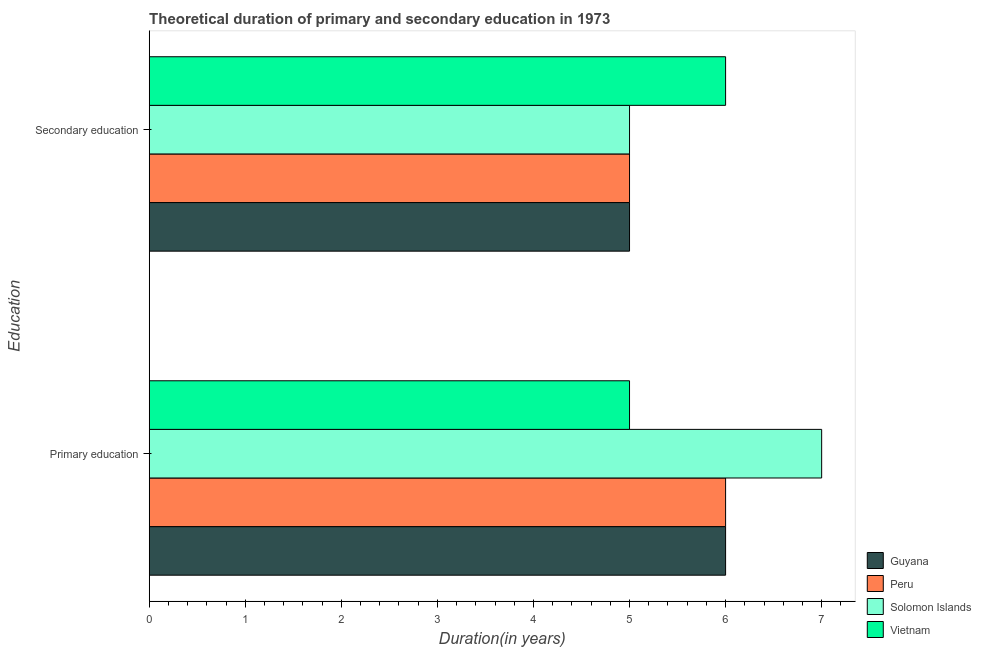What is the label of the 1st group of bars from the top?
Give a very brief answer. Secondary education. What is the duration of secondary education in Peru?
Provide a succinct answer. 5. Across all countries, what is the minimum duration of primary education?
Provide a succinct answer. 5. In which country was the duration of secondary education maximum?
Make the answer very short. Vietnam. In which country was the duration of primary education minimum?
Your answer should be compact. Vietnam. What is the total duration of primary education in the graph?
Offer a very short reply. 24. What is the difference between the duration of primary education in Guyana and that in Vietnam?
Your answer should be compact. 1. What is the difference between the duration of secondary education in Solomon Islands and the duration of primary education in Guyana?
Ensure brevity in your answer.  -1. What is the average duration of secondary education per country?
Keep it short and to the point. 5.25. What is the difference between the duration of secondary education and duration of primary education in Solomon Islands?
Ensure brevity in your answer.  -2. In how many countries, is the duration of secondary education greater than 1.8 years?
Ensure brevity in your answer.  4. Is the duration of primary education in Peru less than that in Solomon Islands?
Provide a succinct answer. Yes. In how many countries, is the duration of primary education greater than the average duration of primary education taken over all countries?
Ensure brevity in your answer.  1. What does the 2nd bar from the top in Secondary education represents?
Offer a very short reply. Solomon Islands. What does the 1st bar from the bottom in Primary education represents?
Provide a succinct answer. Guyana. Are all the bars in the graph horizontal?
Your response must be concise. Yes. Are the values on the major ticks of X-axis written in scientific E-notation?
Your answer should be very brief. No. How many legend labels are there?
Give a very brief answer. 4. How are the legend labels stacked?
Provide a short and direct response. Vertical. What is the title of the graph?
Make the answer very short. Theoretical duration of primary and secondary education in 1973. What is the label or title of the X-axis?
Your answer should be compact. Duration(in years). What is the label or title of the Y-axis?
Provide a short and direct response. Education. What is the Duration(in years) of Guyana in Primary education?
Offer a very short reply. 6. What is the Duration(in years) in Peru in Primary education?
Give a very brief answer. 6. What is the Duration(in years) in Vietnam in Primary education?
Your answer should be compact. 5. What is the Duration(in years) of Solomon Islands in Secondary education?
Offer a terse response. 5. What is the Duration(in years) in Vietnam in Secondary education?
Ensure brevity in your answer.  6. Across all Education, what is the maximum Duration(in years) in Peru?
Provide a short and direct response. 6. Across all Education, what is the maximum Duration(in years) of Solomon Islands?
Keep it short and to the point. 7. Across all Education, what is the maximum Duration(in years) of Vietnam?
Give a very brief answer. 6. Across all Education, what is the minimum Duration(in years) of Guyana?
Give a very brief answer. 5. Across all Education, what is the minimum Duration(in years) of Peru?
Provide a short and direct response. 5. What is the total Duration(in years) in Peru in the graph?
Your answer should be very brief. 11. What is the difference between the Duration(in years) of Peru in Primary education and that in Secondary education?
Offer a terse response. 1. What is the difference between the Duration(in years) of Solomon Islands in Primary education and that in Secondary education?
Keep it short and to the point. 2. What is the difference between the Duration(in years) of Guyana in Primary education and the Duration(in years) of Solomon Islands in Secondary education?
Give a very brief answer. 1. What is the difference between the Duration(in years) in Peru in Primary education and the Duration(in years) in Solomon Islands in Secondary education?
Keep it short and to the point. 1. What is the difference between the Duration(in years) of Peru in Primary education and the Duration(in years) of Vietnam in Secondary education?
Provide a succinct answer. 0. What is the average Duration(in years) of Guyana per Education?
Offer a very short reply. 5.5. What is the average Duration(in years) of Peru per Education?
Provide a short and direct response. 5.5. What is the average Duration(in years) of Vietnam per Education?
Provide a short and direct response. 5.5. What is the difference between the Duration(in years) of Guyana and Duration(in years) of Peru in Primary education?
Your answer should be compact. 0. What is the difference between the Duration(in years) of Guyana and Duration(in years) of Solomon Islands in Primary education?
Keep it short and to the point. -1. What is the difference between the Duration(in years) of Guyana and Duration(in years) of Vietnam in Primary education?
Offer a very short reply. 1. What is the difference between the Duration(in years) in Peru and Duration(in years) in Solomon Islands in Primary education?
Offer a very short reply. -1. What is the difference between the Duration(in years) of Solomon Islands and Duration(in years) of Vietnam in Primary education?
Your answer should be compact. 2. What is the difference between the Duration(in years) in Guyana and Duration(in years) in Vietnam in Secondary education?
Your answer should be compact. -1. What is the difference between the Duration(in years) of Peru and Duration(in years) of Solomon Islands in Secondary education?
Provide a short and direct response. 0. What is the difference between the Duration(in years) of Peru and Duration(in years) of Vietnam in Secondary education?
Keep it short and to the point. -1. What is the difference between the Duration(in years) in Solomon Islands and Duration(in years) in Vietnam in Secondary education?
Your answer should be very brief. -1. What is the ratio of the Duration(in years) in Guyana in Primary education to that in Secondary education?
Your answer should be compact. 1.2. What is the difference between the highest and the second highest Duration(in years) in Peru?
Offer a terse response. 1. What is the difference between the highest and the second highest Duration(in years) of Solomon Islands?
Make the answer very short. 2. What is the difference between the highest and the lowest Duration(in years) of Guyana?
Your answer should be compact. 1. What is the difference between the highest and the lowest Duration(in years) in Solomon Islands?
Your answer should be compact. 2. What is the difference between the highest and the lowest Duration(in years) in Vietnam?
Your response must be concise. 1. 